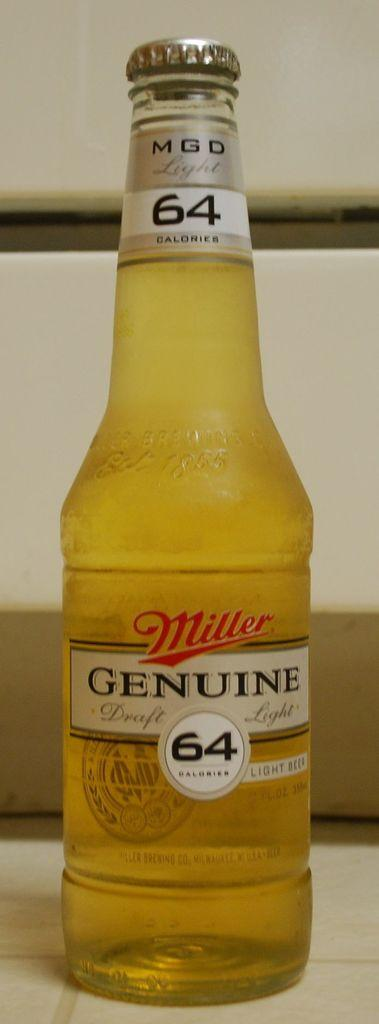<image>
Present a compact description of the photo's key features. A full bottle of Miller Genuine Draft Light beer. 